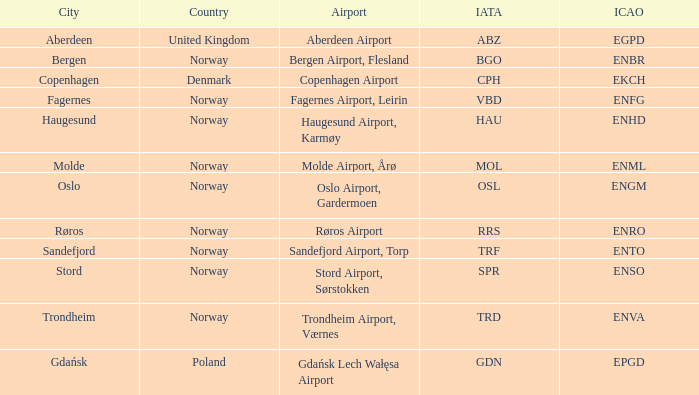In what Country is Haugesund? Norway. 